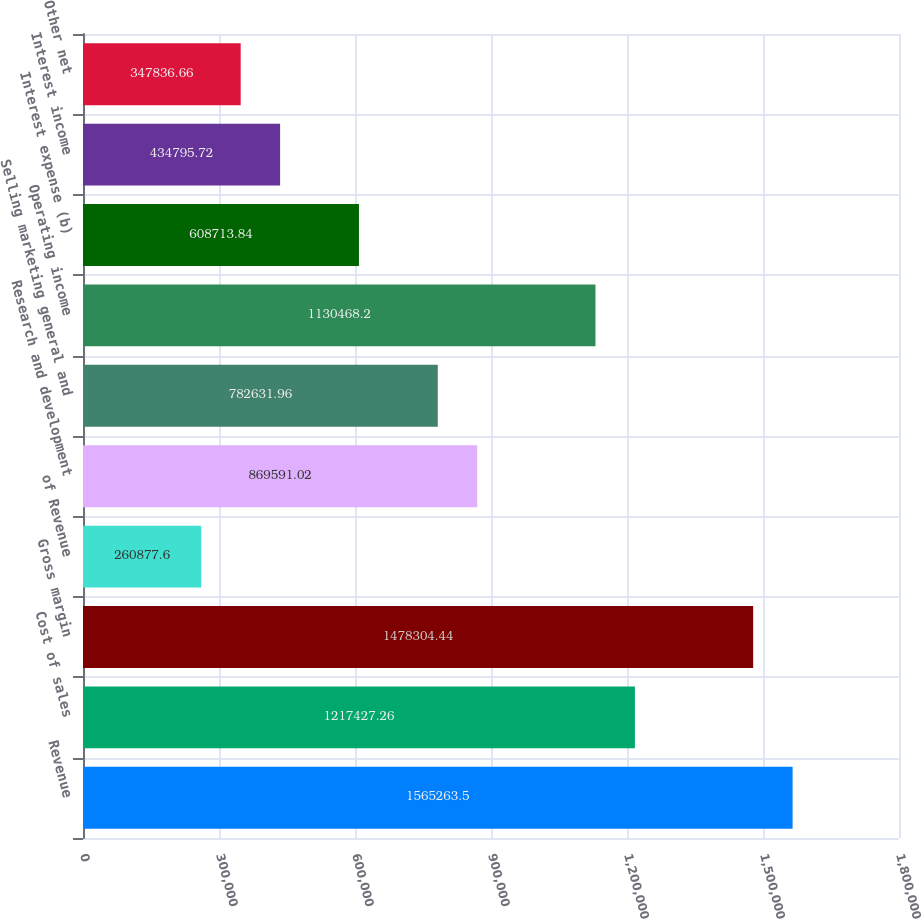Convert chart. <chart><loc_0><loc_0><loc_500><loc_500><bar_chart><fcel>Revenue<fcel>Cost of sales<fcel>Gross margin<fcel>of Revenue<fcel>Research and development<fcel>Selling marketing general and<fcel>Operating income<fcel>Interest expense (b)<fcel>Interest income<fcel>Other net<nl><fcel>1.56526e+06<fcel>1.21743e+06<fcel>1.4783e+06<fcel>260878<fcel>869591<fcel>782632<fcel>1.13047e+06<fcel>608714<fcel>434796<fcel>347837<nl></chart> 